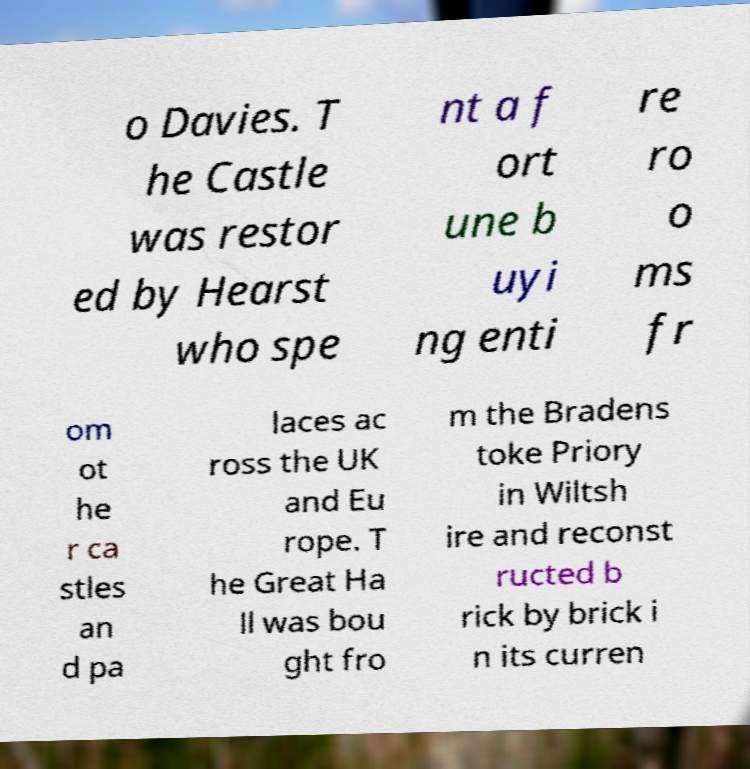Can you read and provide the text displayed in the image?This photo seems to have some interesting text. Can you extract and type it out for me? o Davies. T he Castle was restor ed by Hearst who spe nt a f ort une b uyi ng enti re ro o ms fr om ot he r ca stles an d pa laces ac ross the UK and Eu rope. T he Great Ha ll was bou ght fro m the Bradens toke Priory in Wiltsh ire and reconst ructed b rick by brick i n its curren 